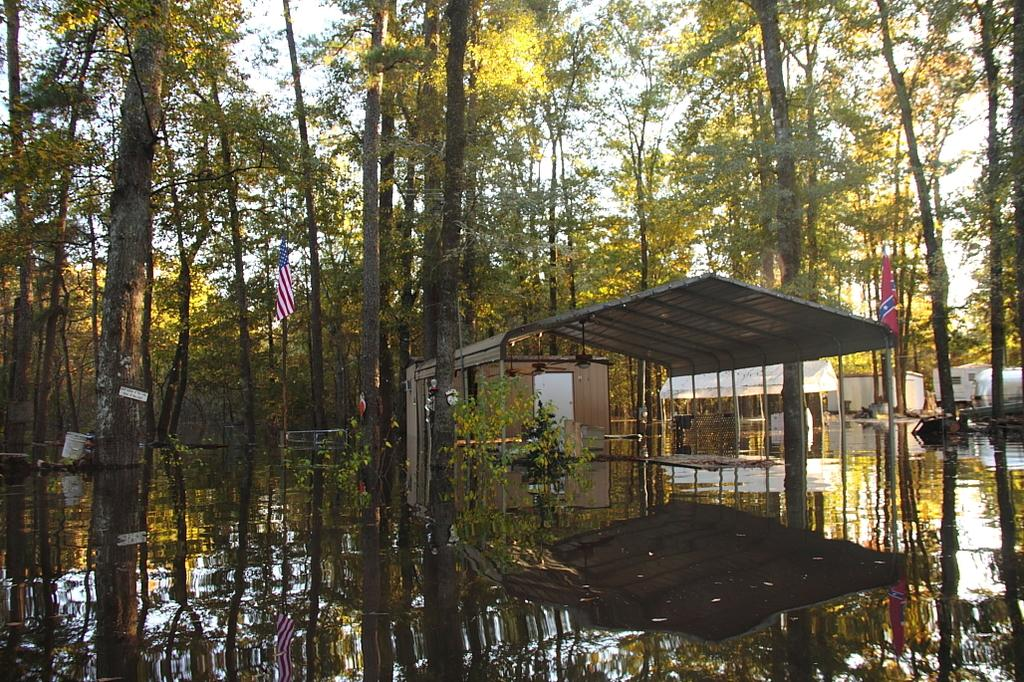What type of vegetation can be seen in the image? There are trees in the image. What type of structure is present in the image? There is a shed in the image. What natural element is visible in the image? There is water visible in the image. What decorative items are on the shed in the image? There are flags on the shed in the image. What type of knee support is visible in the image? There is no knee support present in the image. What taste sensation can be experienced from the water in the image? The image does not provide any information about the taste of the water. 